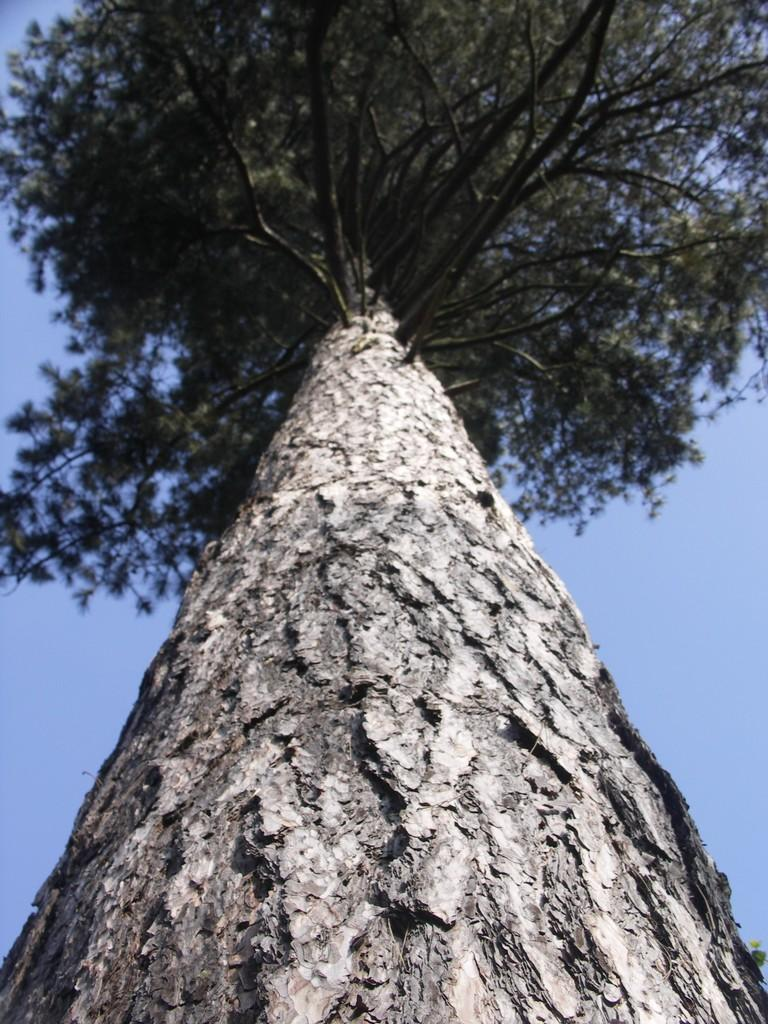What type of natural object can be seen in the image? There is a tree in the image. What part of the natural environment is visible in the background of the image? The sky is visible in the background of the image. What type of adjustment can be seen on the tree in the image? There is no adjustment visible on the tree in the image. What type of mineral is present in the image? There is no mineral present in the image; it features a tree and the sky. 